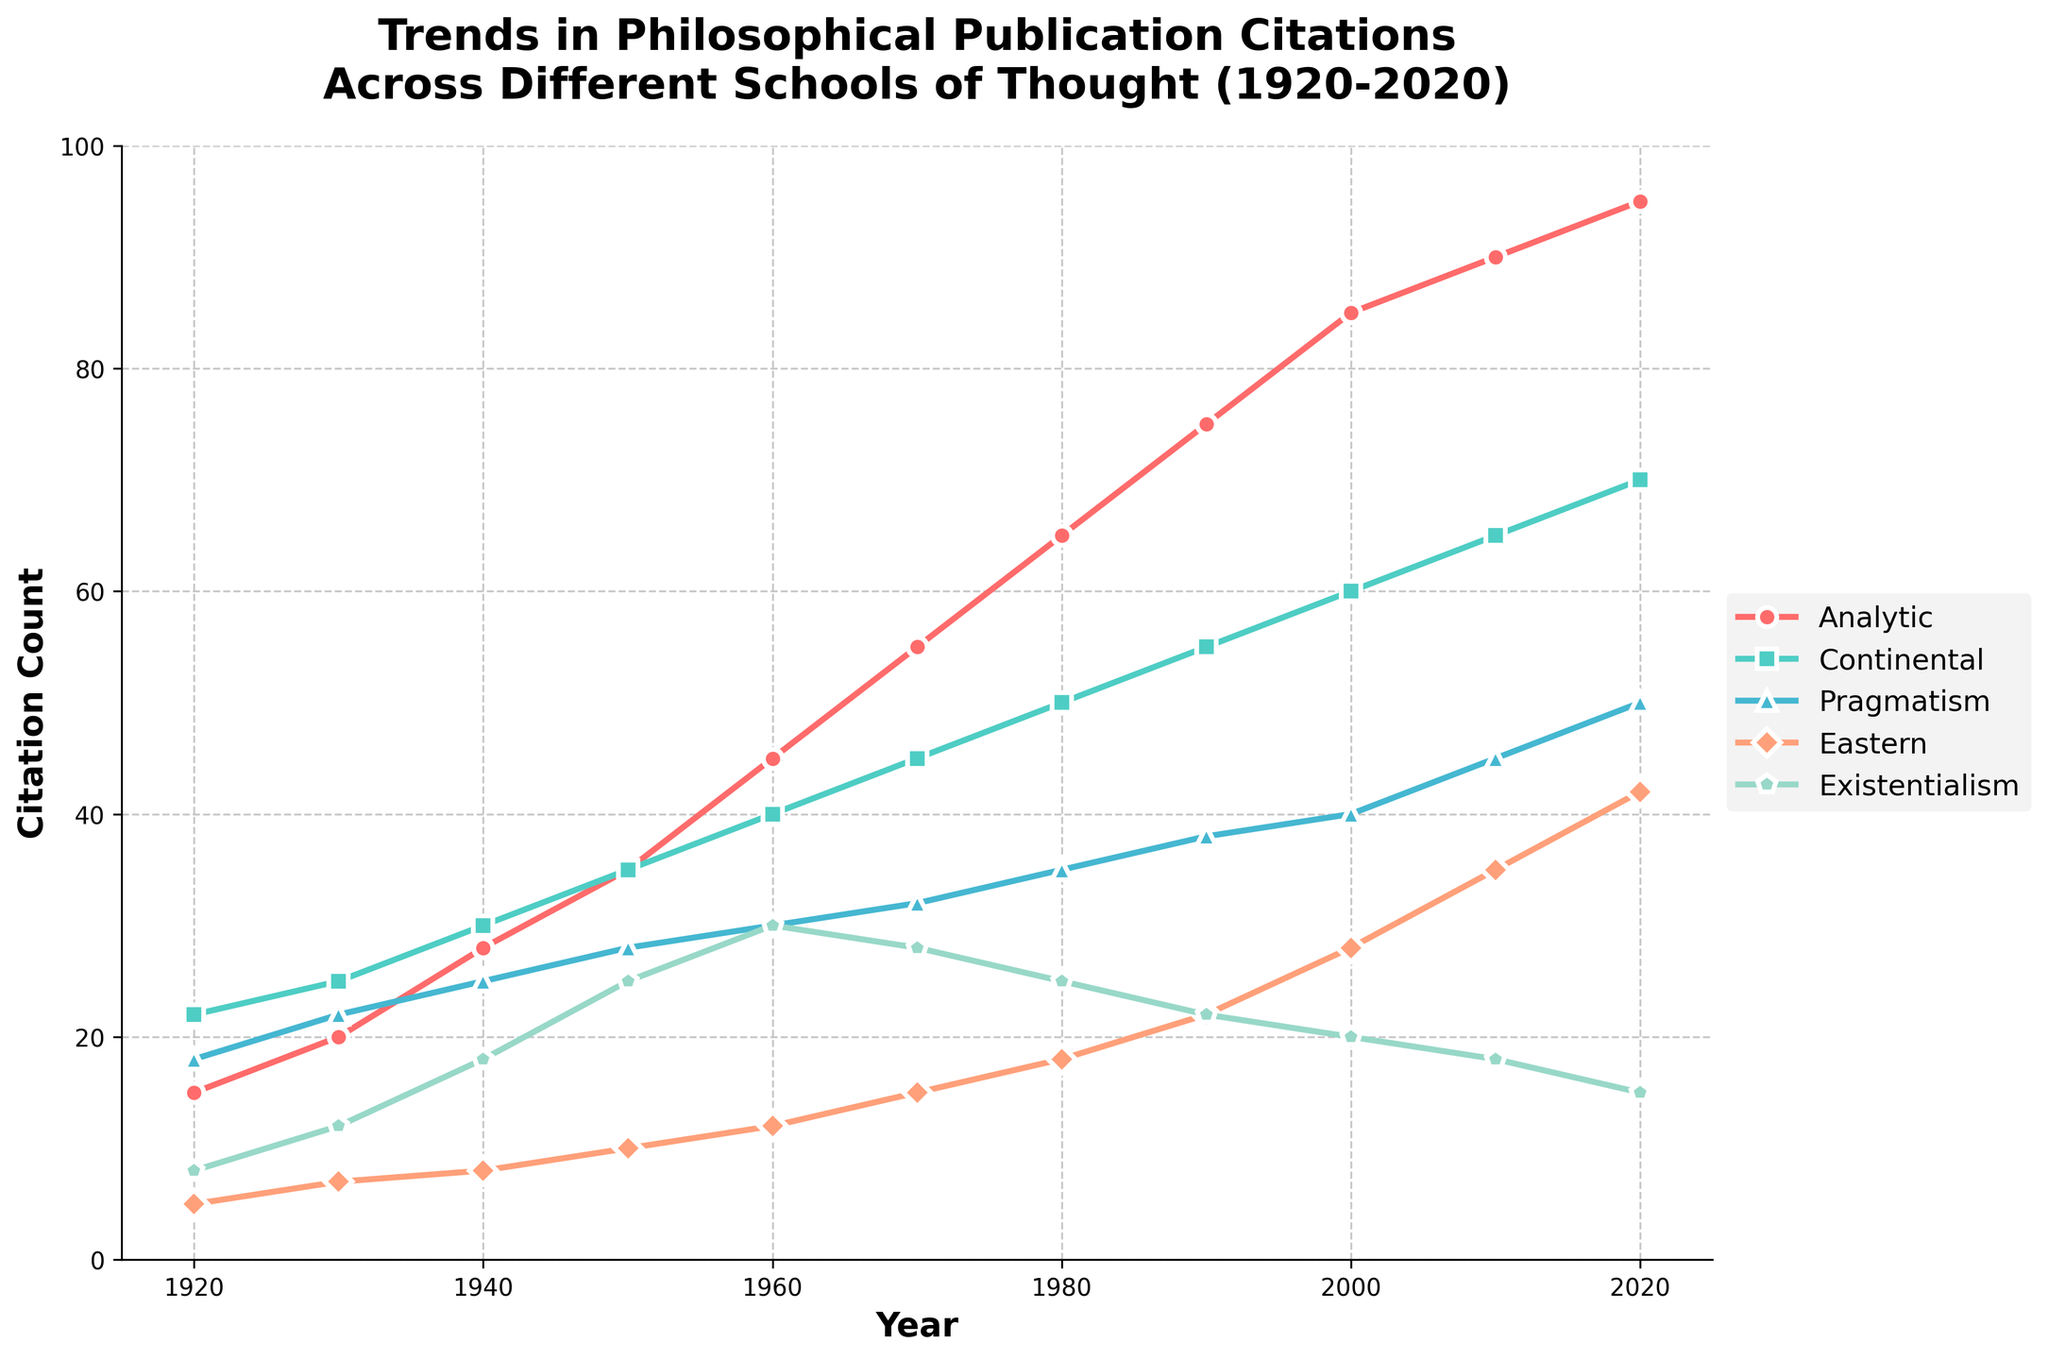What was the trend for citations in "Existentialism" from 1920 to 2020? The citation count for "Existentialism" increased steadily from 8 in 1920 to its peak of 30 in 1960. After that, it began to decline gradually to 15 by 2020.
Answer: Increased to 1960, then declined Which school of thought had the highest citation count in 1940? To determine this, we look for the school with the highest y-value in 1940. "Continental" had the highest citation count with 30.
Answer: Continental By how much did the citations for "Analytic" philosophy increase between 1920 and 2020? Subtract the citation count for "Analytic" philosophy in 1920 from that in 2020: 95 - 15 = 80
Answer: 80 Compare the trends of "Pragmatism" and "Eastern" philosophies from 2000 to 2020. From 2000 to 2020, citations for "Pragmatism" increased from 40 to 50, while citations for "Eastern" philosophies increased from 28 to 42. Both trends show an upward movement, but "Eastern" had a steeper increase.
Answer: Both increased, but Eastern more steeply What is the difference in citation counts between "Analytic" and "Existentialism" in 2020? To find the difference, subtract the citation count of "Existentialism" from that of "Analytic" in 2020: 95 - 15 = 80
Answer: 80 Which school had the highest growth rate in citations from 1920 to 2020? By calculating the ratio of citation counts in 2020 to those in 1920 for each school: Analytic (95/15), Continental (70/22), Pragmatism (50/18), Eastern (42/5), Existentialism (15/8). "Eastern" philosophy had the highest growth rate as 42/5 = 8.4.
Answer: Eastern What is the average citation count across all schools in 1970? To find the average, sum the citation counts in 1970 and divide by the number of schools: (55 + 45 + 32 + 15 + 28)/5 = 35
Answer: 35 Which school of thought shows a notable decline in citation counts in the last two decades? Observing the trends from 2000 to 2020, "Existentialism" is the only school showing a clear decline from 20 to 15.
Answer: Existentialism How did the citations for "Continental" and "Eastern" philosophies compare in 1950? In 1950, "Continental" had 35 citations and "Eastern" had 10 citations. "Continental" philosophy had significantly more citations.
Answer: Continental had more 